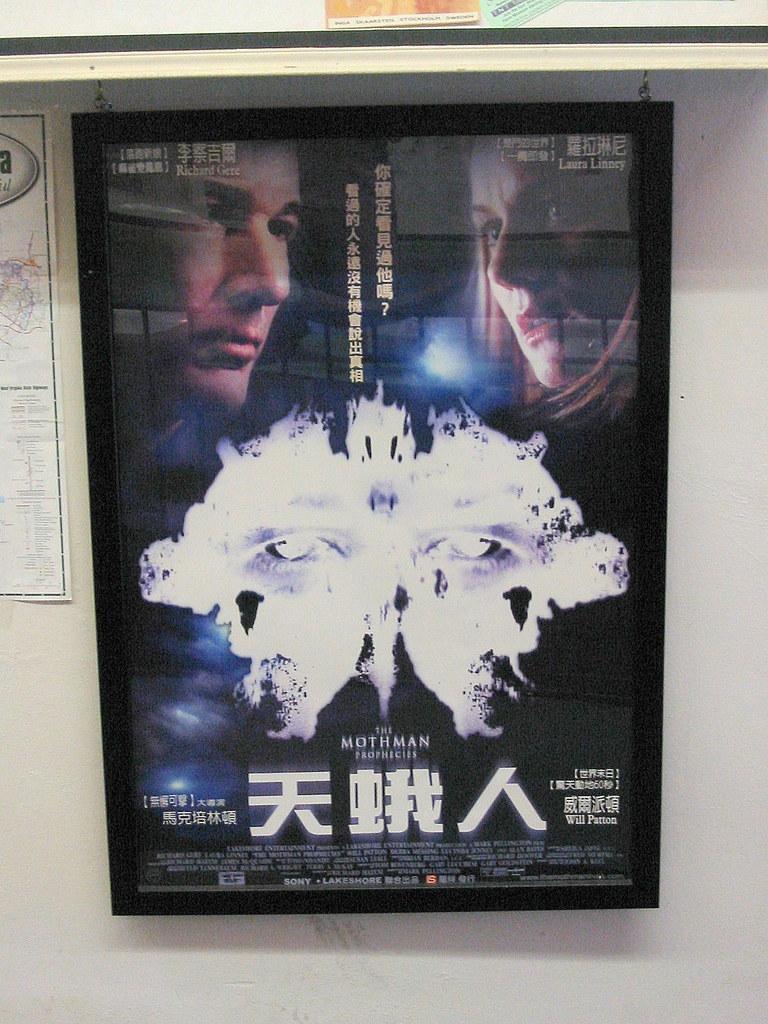What is the title of this movie?
Your response must be concise. The mothman prophecies. What is the name of the male actor?
Ensure brevity in your answer.  Richard gere. 